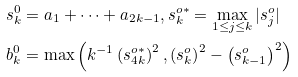Convert formula to latex. <formula><loc_0><loc_0><loc_500><loc_500>s _ { k } ^ { 0 } & = a _ { 1 } + \dots + a _ { 2 k - 1 } , s _ { k } ^ { o \ast } = \max _ { 1 \leq j \leq k } | s _ { j } ^ { o } | \\ b _ { k } ^ { 0 } & = \max \left ( k ^ { - 1 } \left ( s _ { 4 k } ^ { o \ast } \right ) ^ { 2 } , \left ( s _ { k } ^ { o } \right ) ^ { 2 } - \left ( s _ { k - 1 } ^ { o } \right ) ^ { 2 } \right )</formula> 